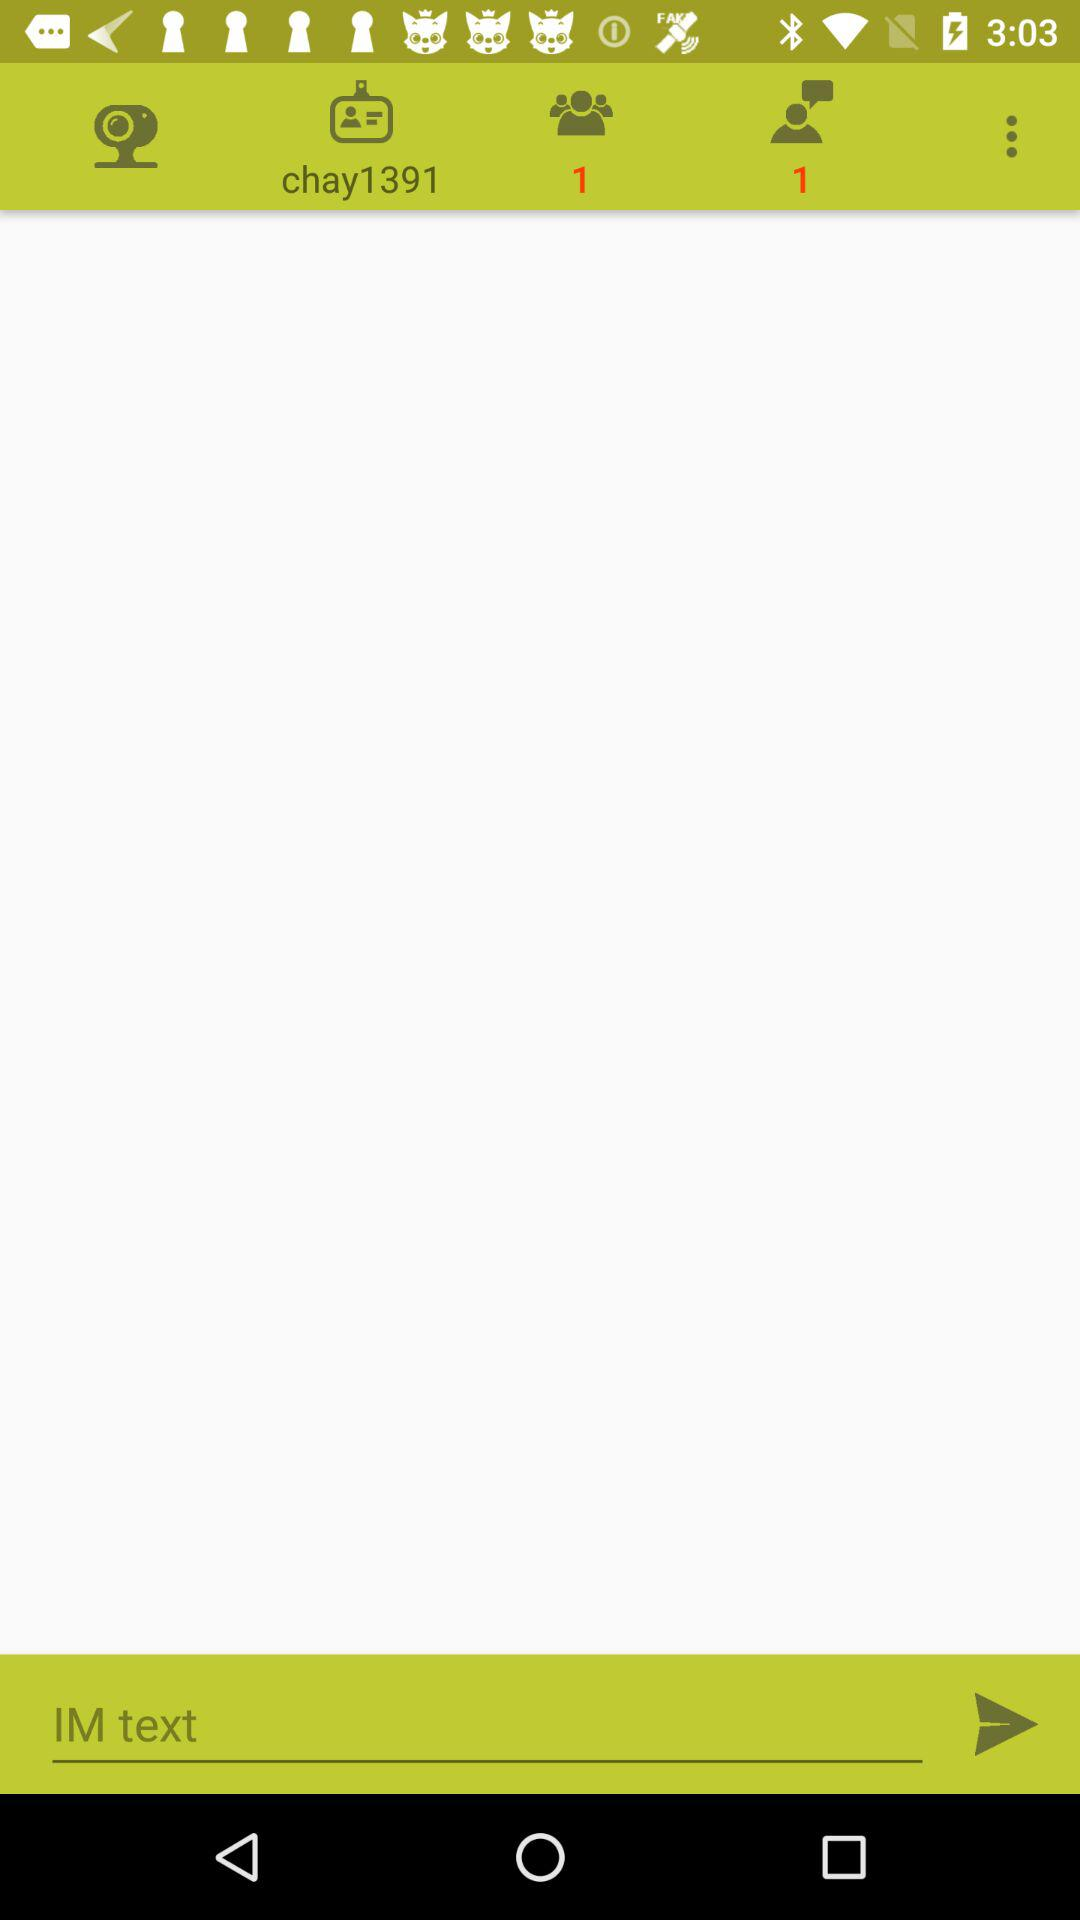How many unread messages are there?
When the provided information is insufficient, respond with <no answer>. <no answer> 